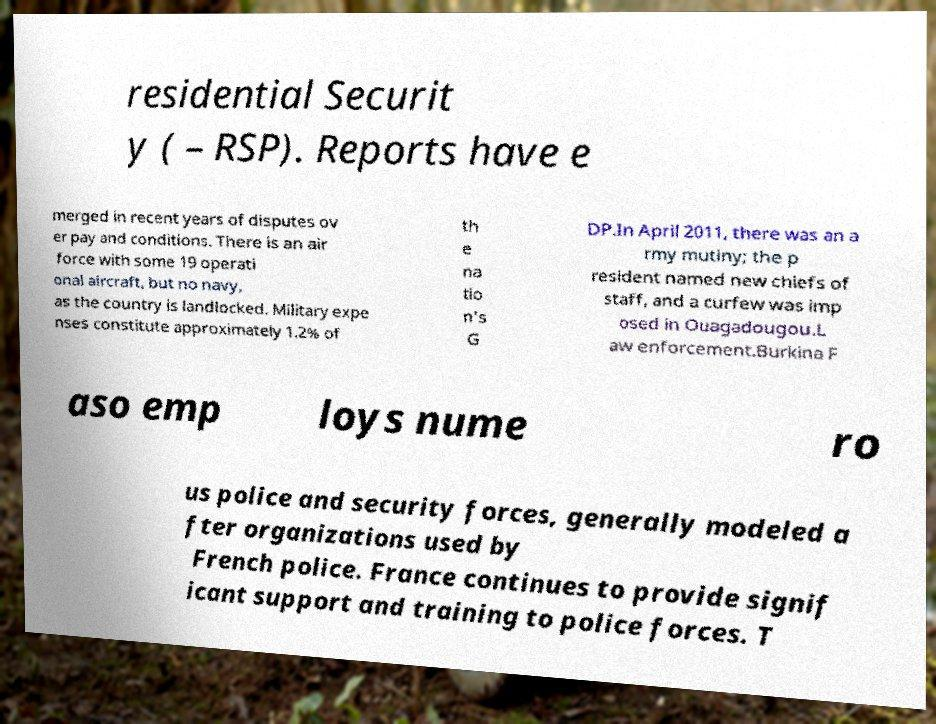Can you accurately transcribe the text from the provided image for me? residential Securit y ( – RSP). Reports have e merged in recent years of disputes ov er pay and conditions. There is an air force with some 19 operati onal aircraft, but no navy, as the country is landlocked. Military expe nses constitute approximately 1.2% of th e na tio n's G DP.In April 2011, there was an a rmy mutiny; the p resident named new chiefs of staff, and a curfew was imp osed in Ouagadougou.L aw enforcement.Burkina F aso emp loys nume ro us police and security forces, generally modeled a fter organizations used by French police. France continues to provide signif icant support and training to police forces. T 